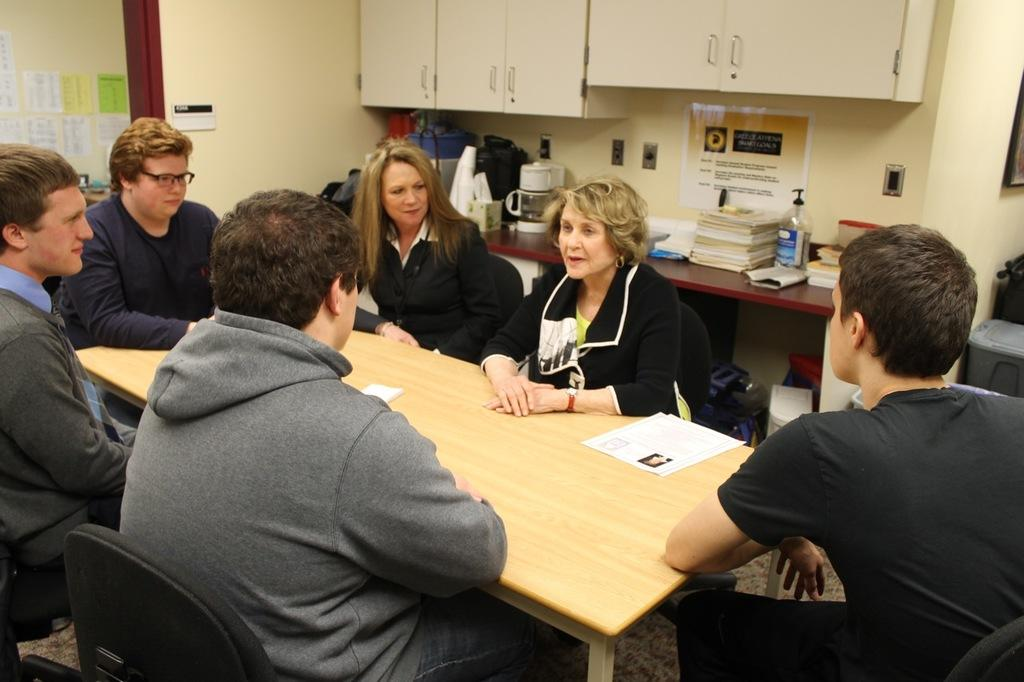How many people are present in the image? There are six people in the image. What are the people doing in the image? The people are sitting on chairs. How are the chairs arranged in the image? The chairs are arranged around a table. What can be seen on the table in the image? There are papers on the table. What can be seen in the background of the image? There is a shelf and a desk in the background of the image. What is placed on the desk in the image? There are items placed on the desk. What type of credit can be seen on the papers on the table? There is no credit visible on the papers in the image; they are just papers. How does the earthquake affect the arrangement of the chairs in the image? There is no earthquake present in the image, so the chairs are not affected by any tremors. 